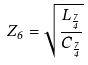<formula> <loc_0><loc_0><loc_500><loc_500>Z _ { 6 } = \sqrt { \frac { L _ { \frac { 7 } { 4 } } } { C _ { \frac { 7 } { 4 } } } }</formula> 